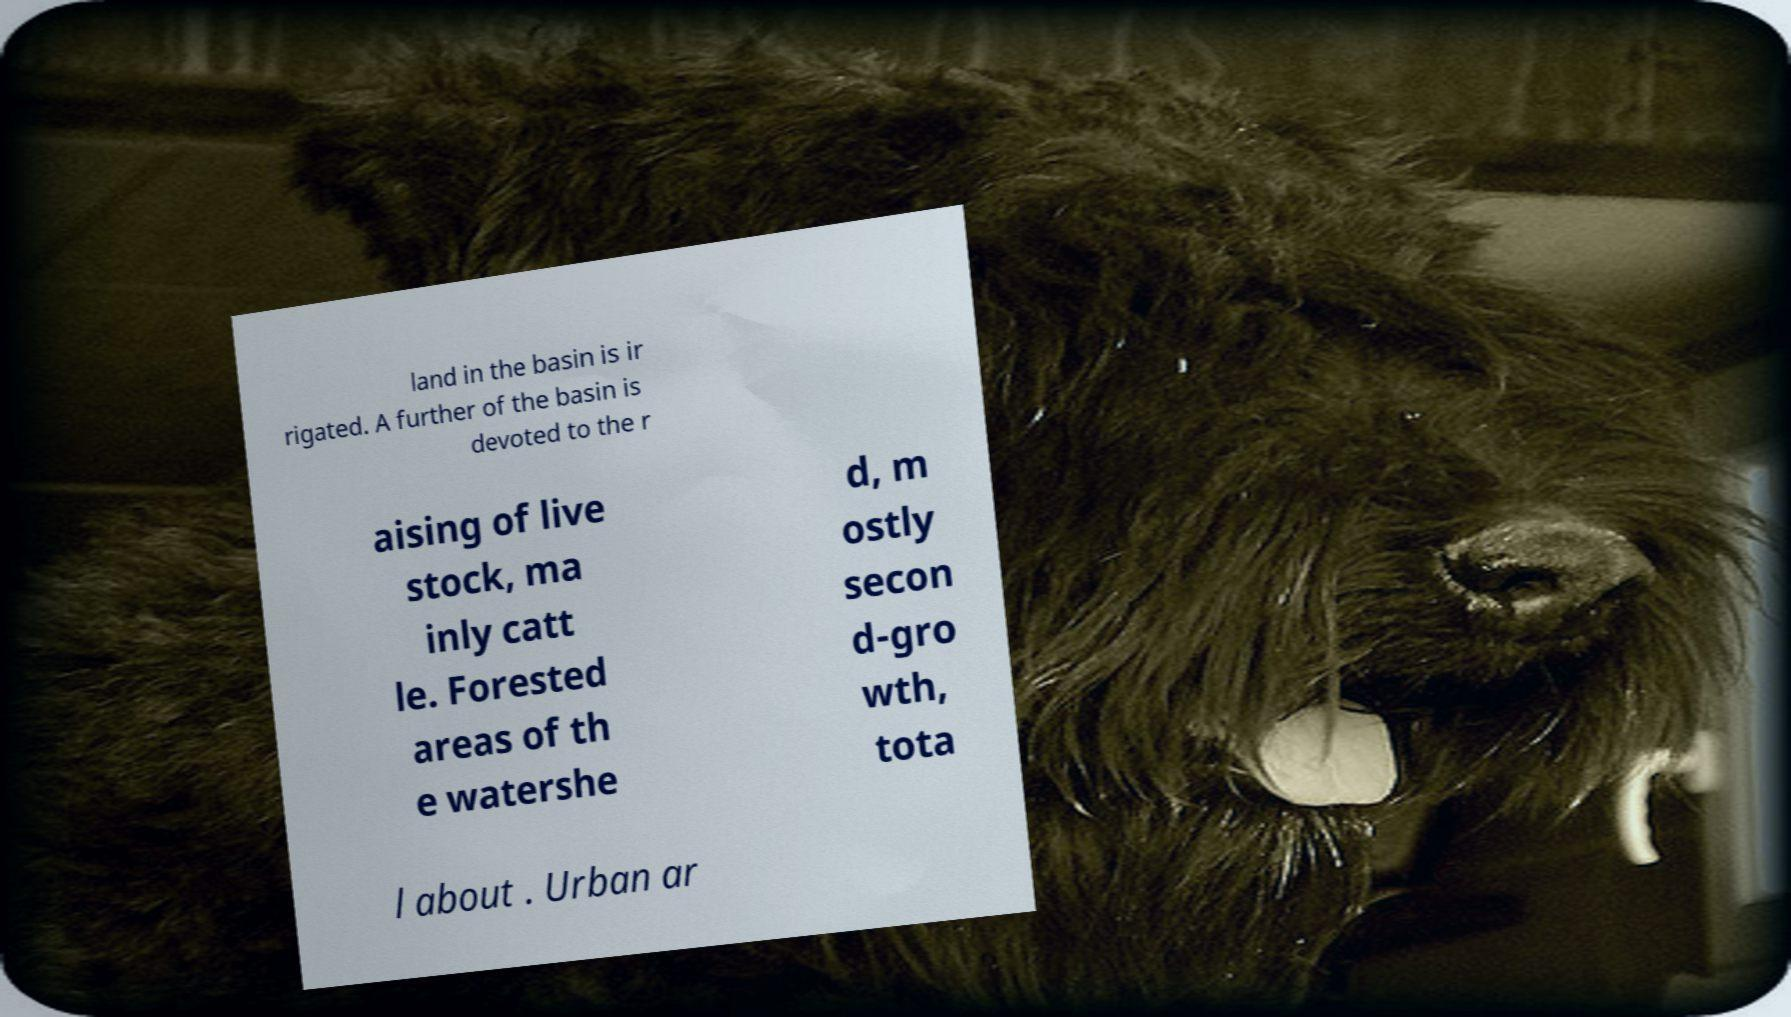Can you read and provide the text displayed in the image?This photo seems to have some interesting text. Can you extract and type it out for me? land in the basin is ir rigated. A further of the basin is devoted to the r aising of live stock, ma inly catt le. Forested areas of th e watershe d, m ostly secon d-gro wth, tota l about . Urban ar 